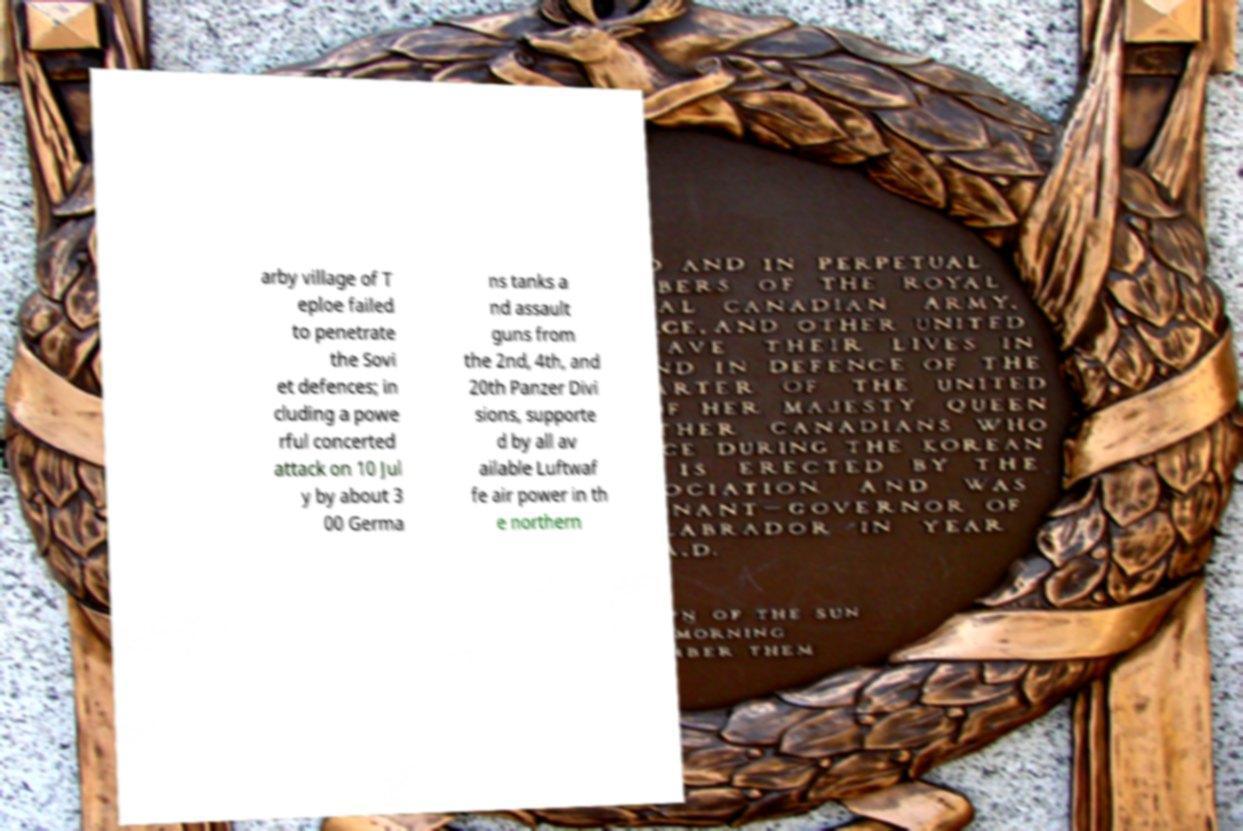What messages or text are displayed in this image? I need them in a readable, typed format. arby village of T eploe failed to penetrate the Sovi et defences; in cluding a powe rful concerted attack on 10 Jul y by about 3 00 Germa ns tanks a nd assault guns from the 2nd, 4th, and 20th Panzer Divi sions, supporte d by all av ailable Luftwaf fe air power in th e northern 